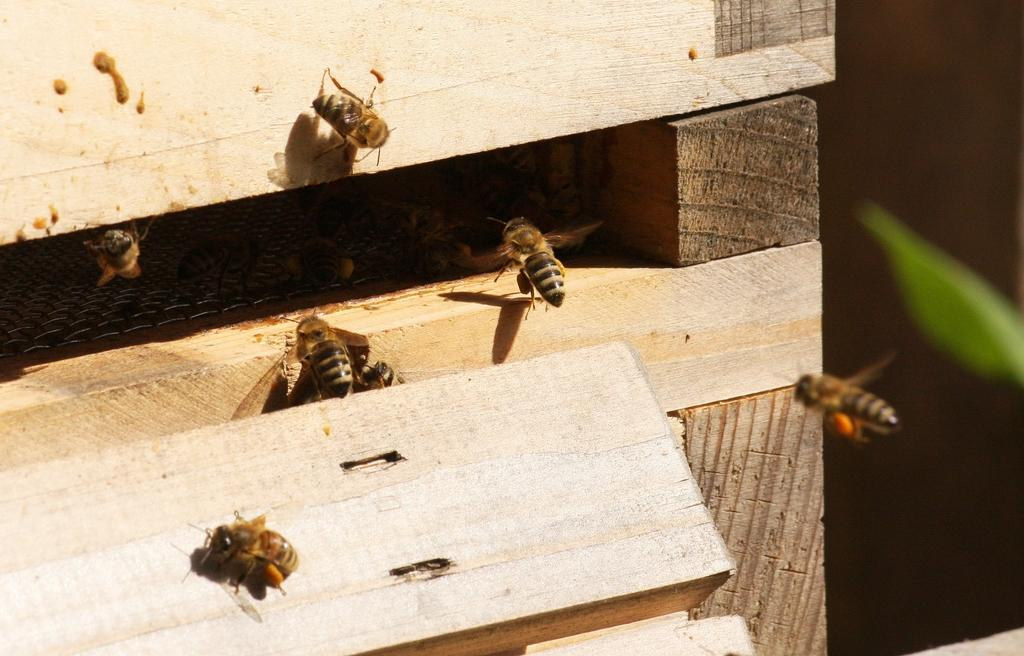What type of insects are present in the image? There are honey bees in the image. What structure is associated with the honey bees in the image? There is a beehive wooden box in the image. What type of picture is hanging on the wall in the image? There is no mention of a picture hanging on the wall in the image; the image only features honey bees and a beehive wooden box. 